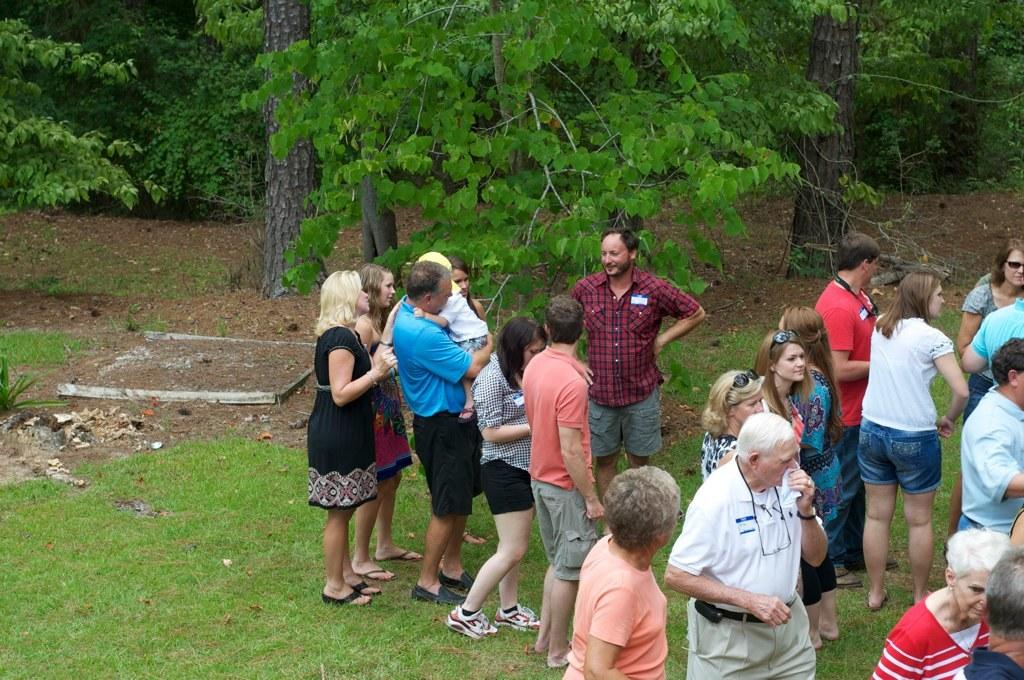How many people are in the image? There is a group of people in the image, but the exact number is not specified. What is the surface the people are standing on? The people are standing on the grass. What other objects or features can be seen in the image? Stones are present in the image. What can be seen in the background of the image? There are trees in the background of the image. What type of yam is being used as a prop by one of the people in the image? There is no yam present in the image; it only features a group of people standing on the grass, stones, and trees in the background. 